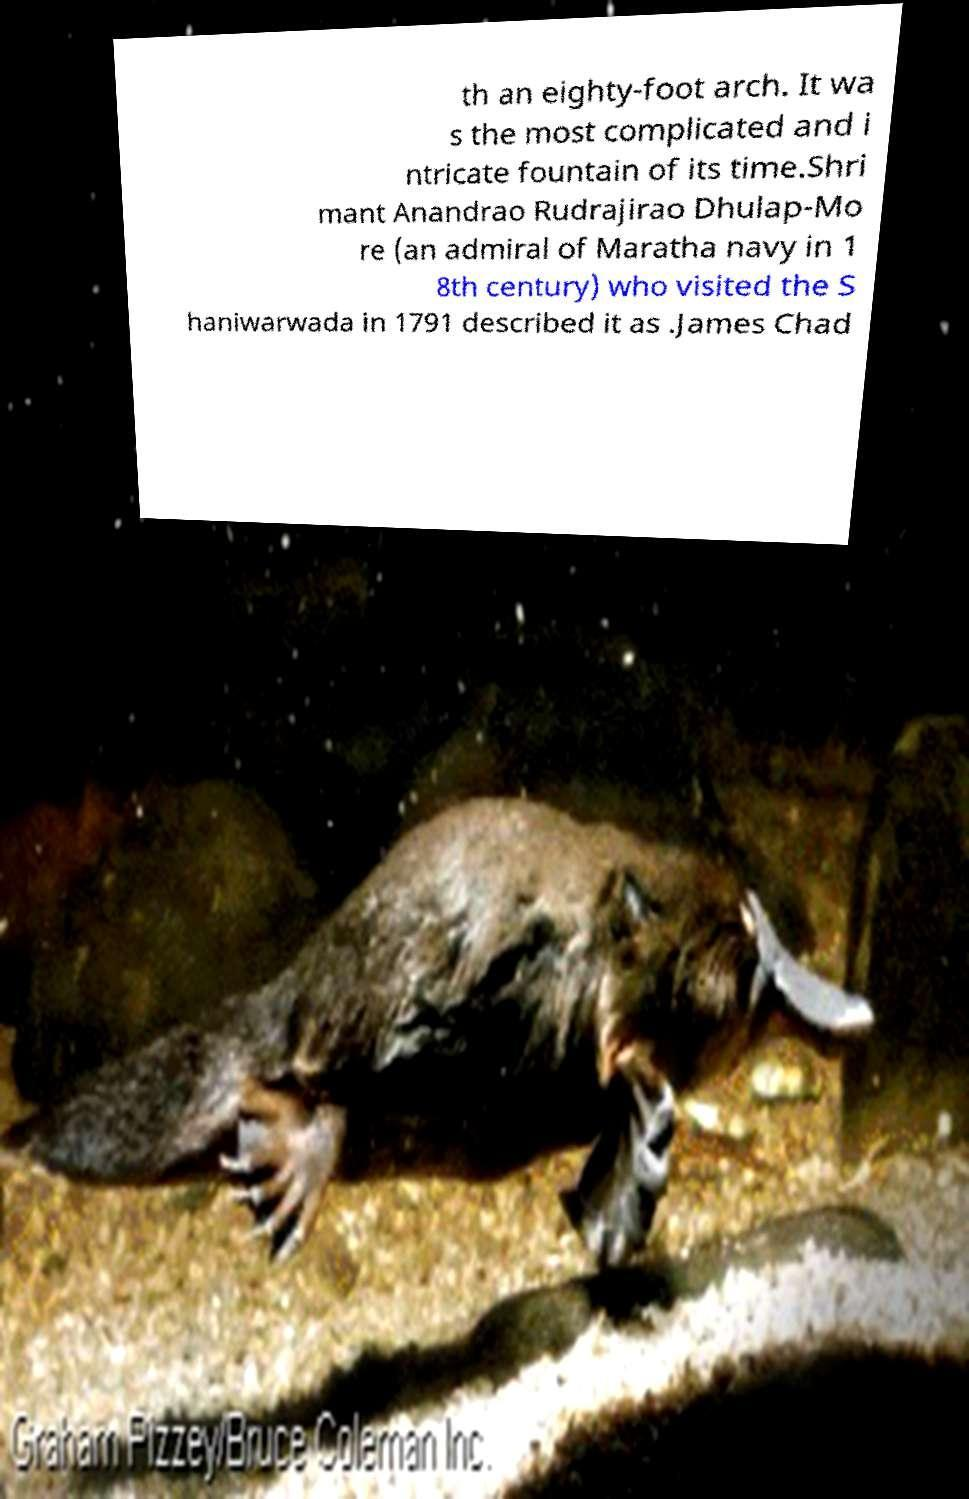Could you assist in decoding the text presented in this image and type it out clearly? th an eighty-foot arch. It wa s the most complicated and i ntricate fountain of its time.Shri mant Anandrao Rudrajirao Dhulap-Mo re (an admiral of Maratha navy in 1 8th century) who visited the S haniwarwada in 1791 described it as .James Chad 